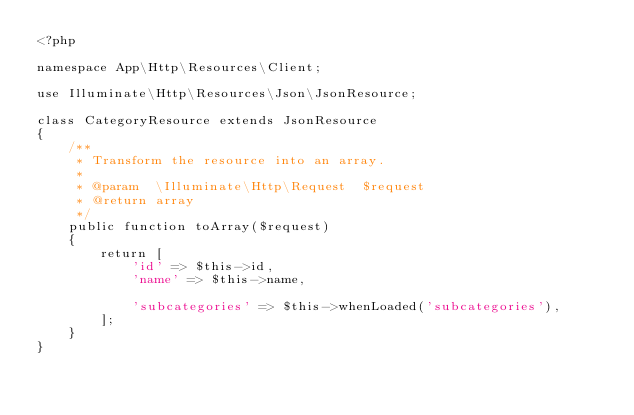<code> <loc_0><loc_0><loc_500><loc_500><_PHP_><?php

namespace App\Http\Resources\Client;

use Illuminate\Http\Resources\Json\JsonResource;

class CategoryResource extends JsonResource
{
    /**
     * Transform the resource into an array.
     *
     * @param  \Illuminate\Http\Request  $request
     * @return array
     */
    public function toArray($request)
    {
        return [
            'id' => $this->id,
            'name' => $this->name,

            'subcategories' => $this->whenLoaded('subcategories'),
        ];
    }
}



</code> 